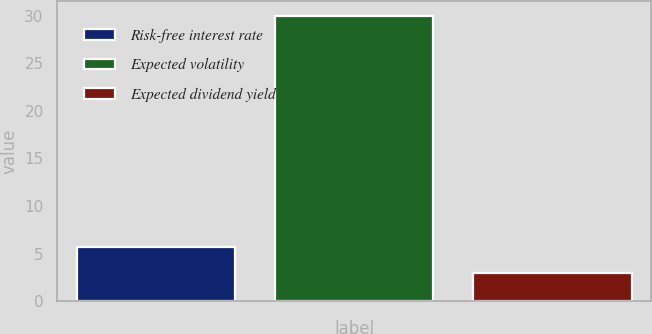Convert chart. <chart><loc_0><loc_0><loc_500><loc_500><bar_chart><fcel>Risk-free interest rate<fcel>Expected volatility<fcel>Expected dividend yield<nl><fcel>5.71<fcel>30<fcel>3.01<nl></chart> 